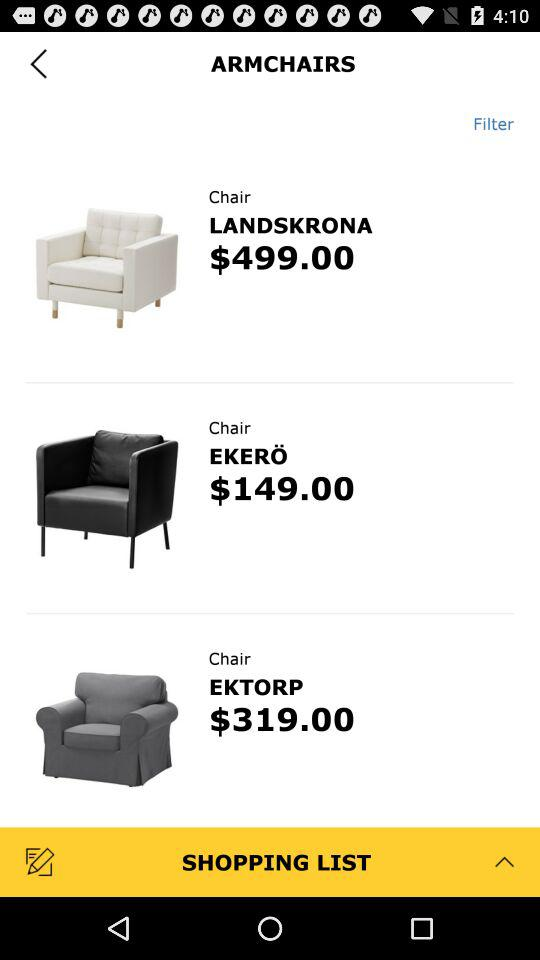What types of chairs are shown? The types of chairs shown are "ARMCHAIRS". 